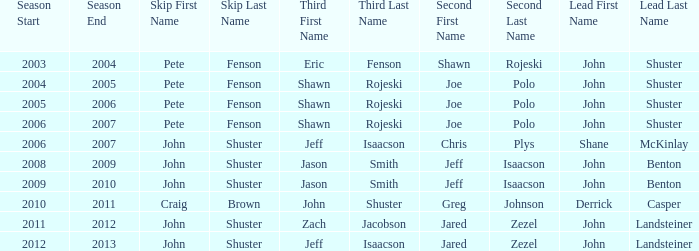Who was the lead with John Shuster as skip in the season of 2009–10? John Benton. 